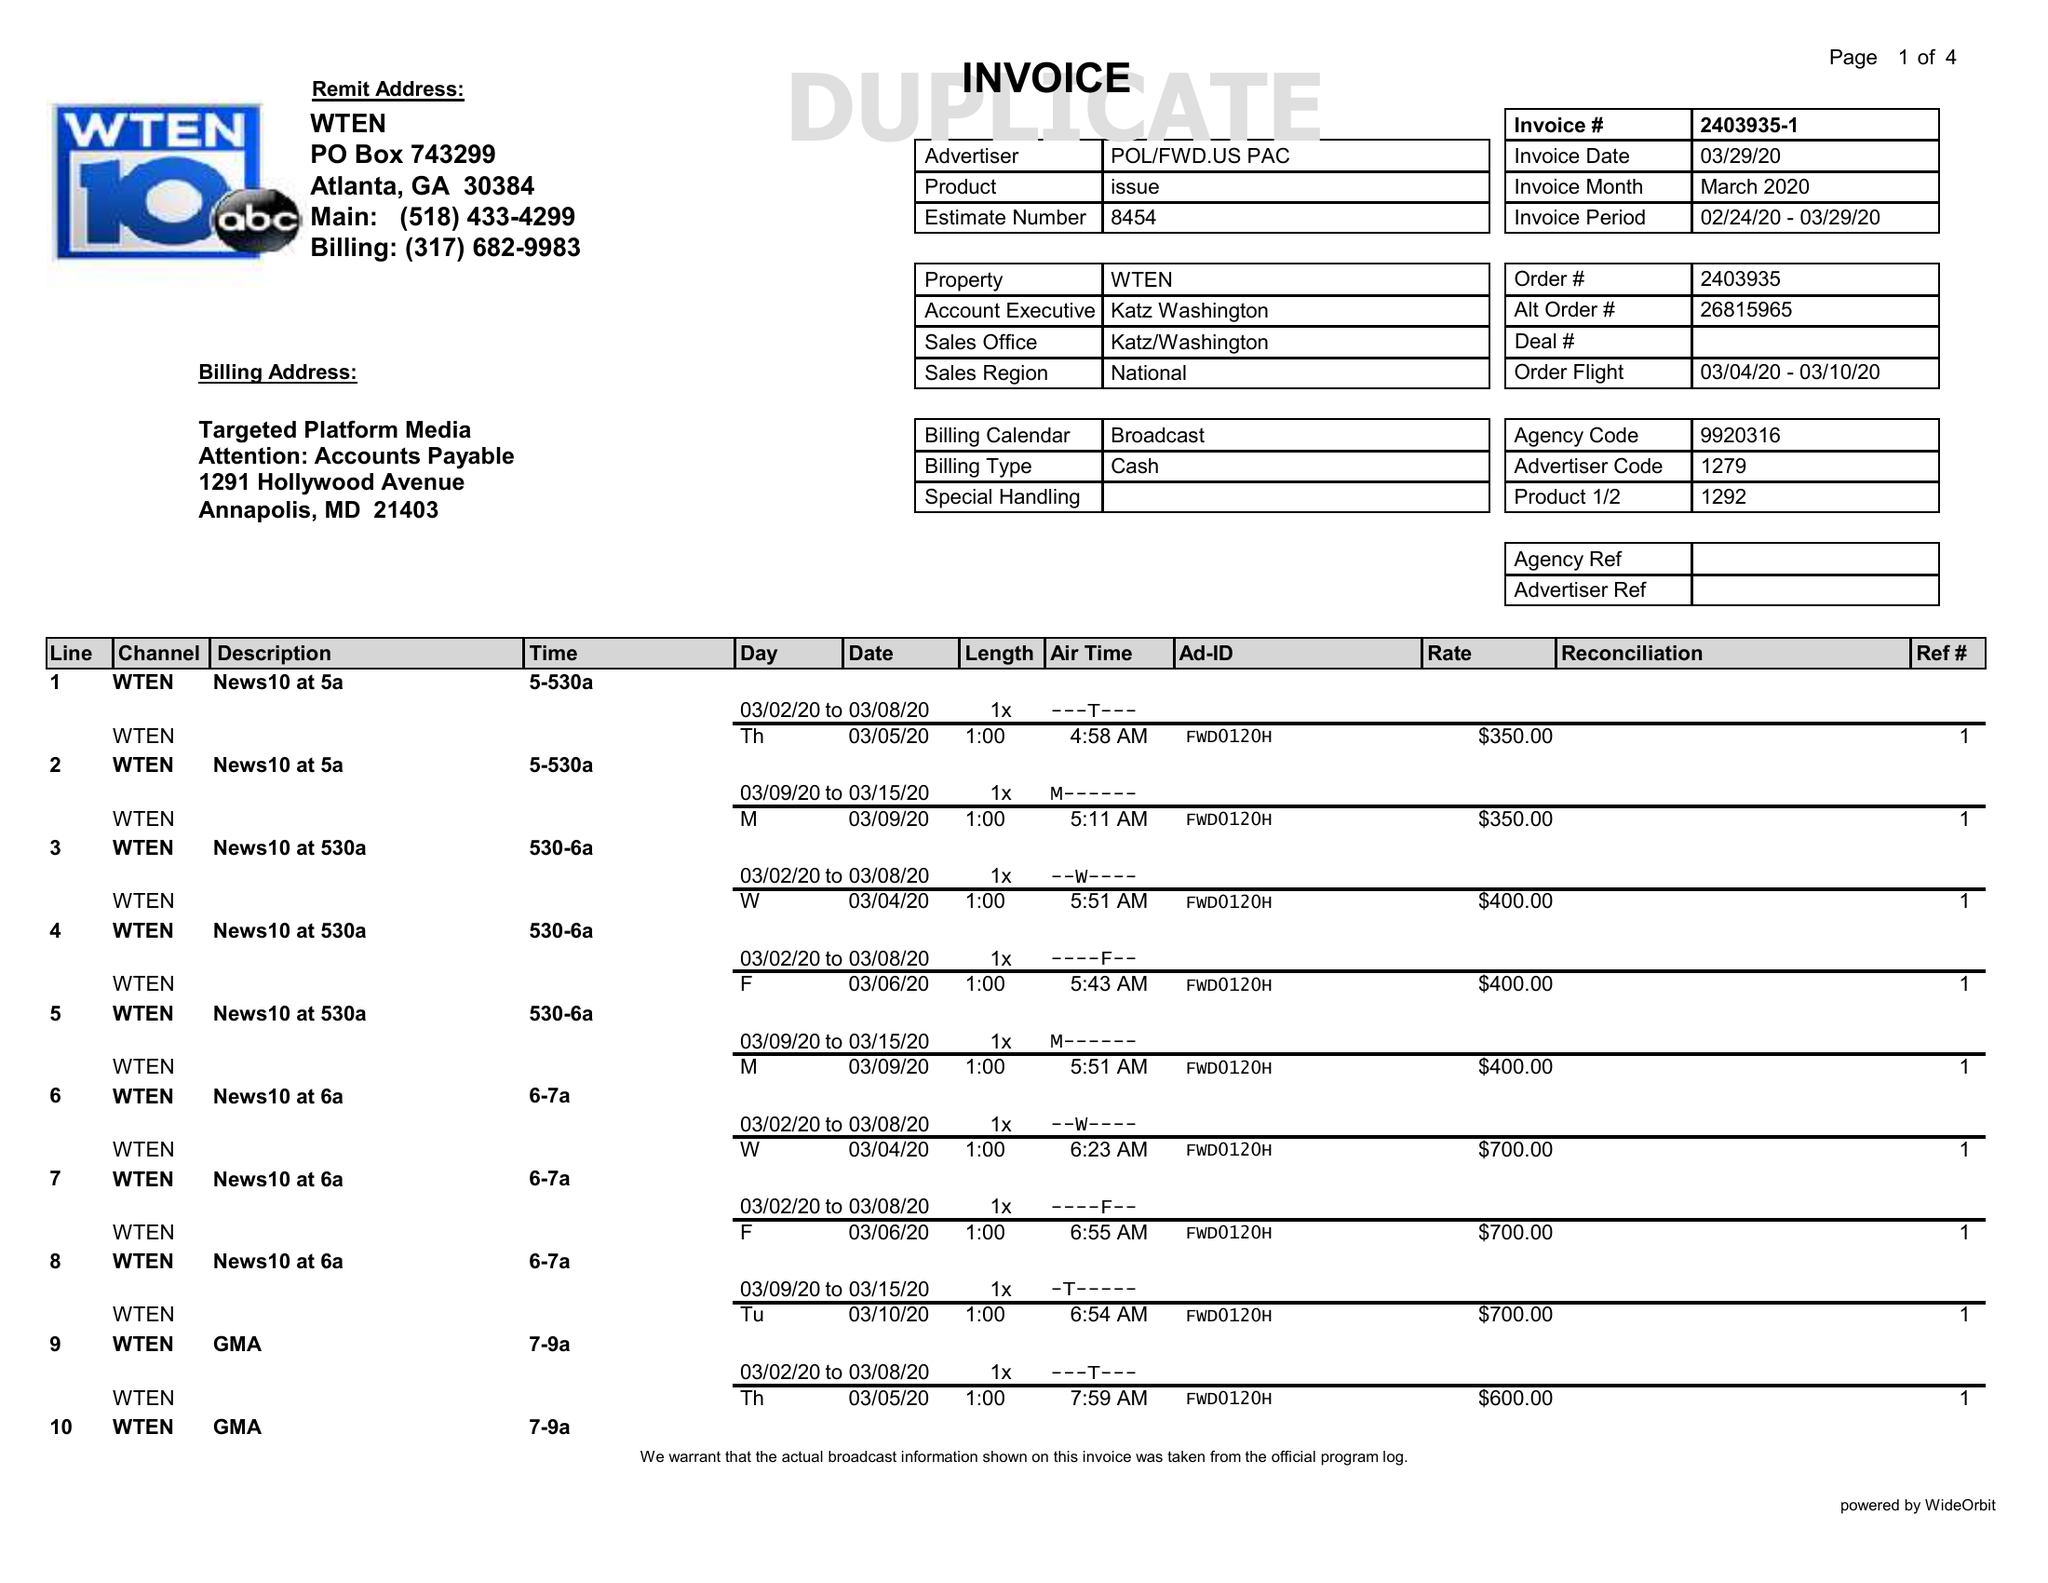What is the value for the contract_num?
Answer the question using a single word or phrase. 2403935 